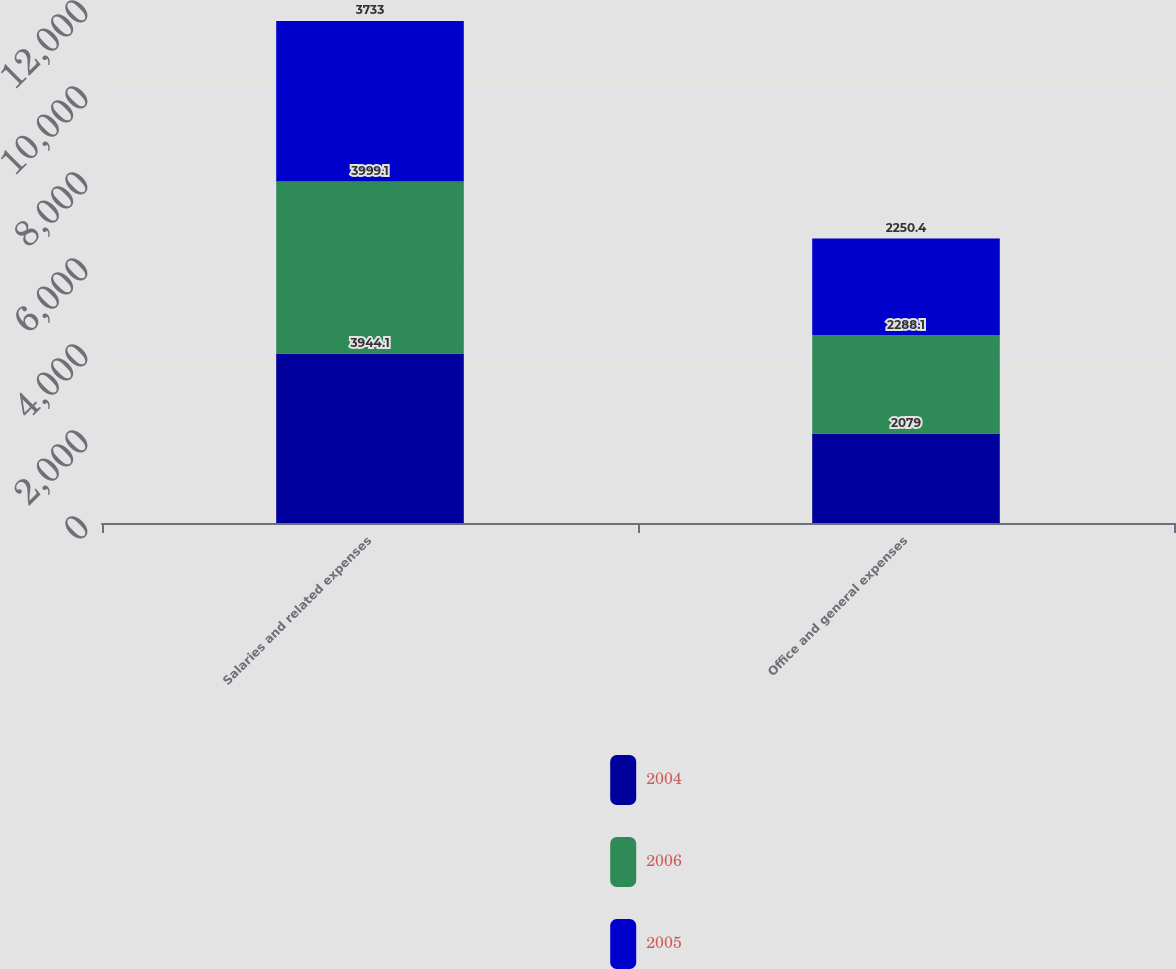Convert chart. <chart><loc_0><loc_0><loc_500><loc_500><stacked_bar_chart><ecel><fcel>Salaries and related expenses<fcel>Office and general expenses<nl><fcel>2004<fcel>3944.1<fcel>2079<nl><fcel>2006<fcel>3999.1<fcel>2288.1<nl><fcel>2005<fcel>3733<fcel>2250.4<nl></chart> 